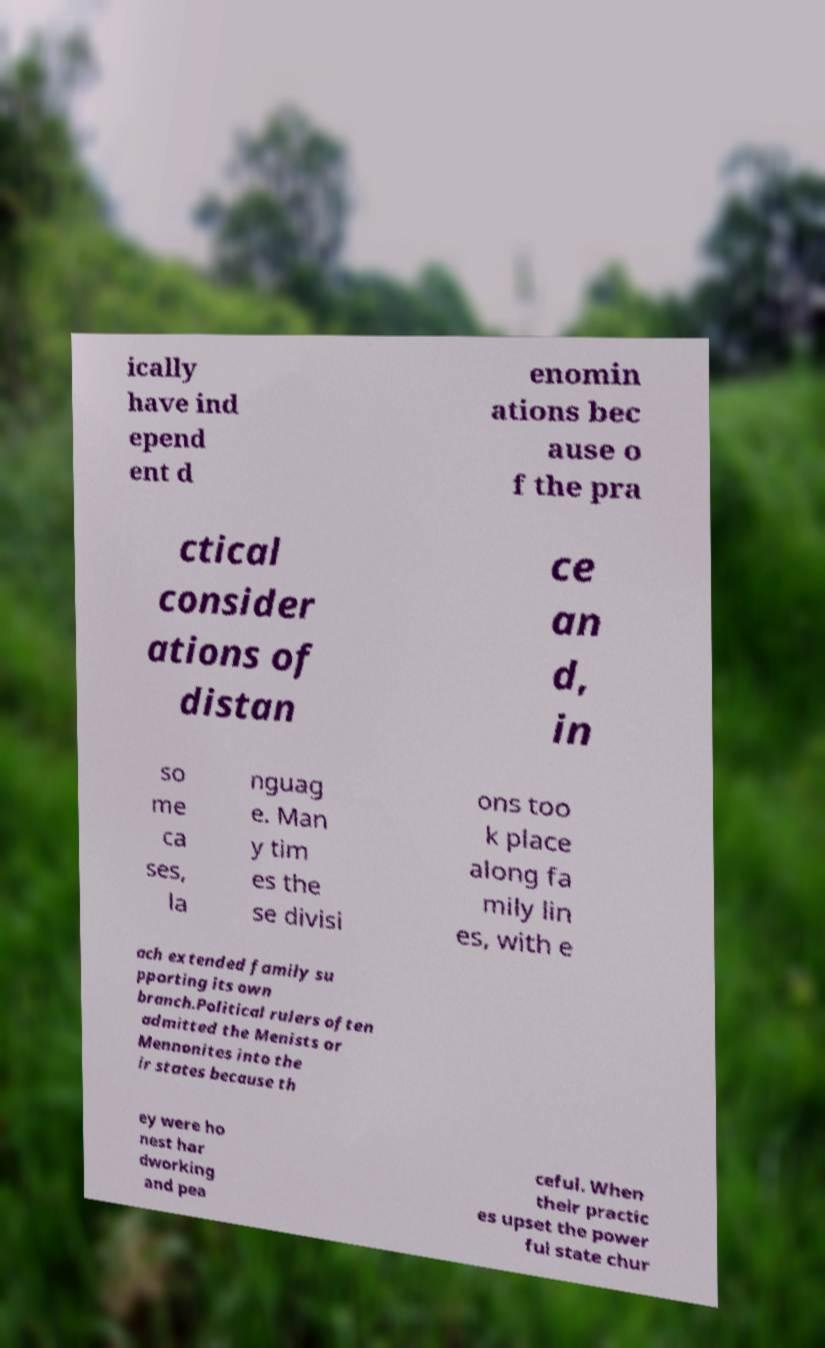I need the written content from this picture converted into text. Can you do that? ically have ind epend ent d enomin ations bec ause o f the pra ctical consider ations of distan ce an d, in so me ca ses, la nguag e. Man y tim es the se divisi ons too k place along fa mily lin es, with e ach extended family su pporting its own branch.Political rulers often admitted the Menists or Mennonites into the ir states because th ey were ho nest har dworking and pea ceful. When their practic es upset the power ful state chur 